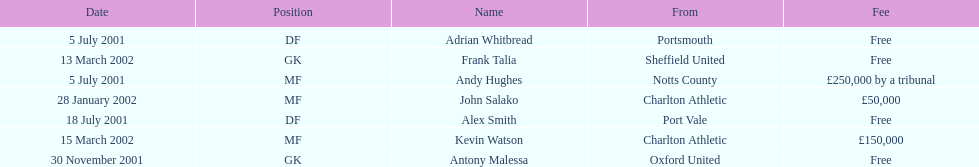Did andy hughes or john salako command the largest fee? Andy Hughes. 